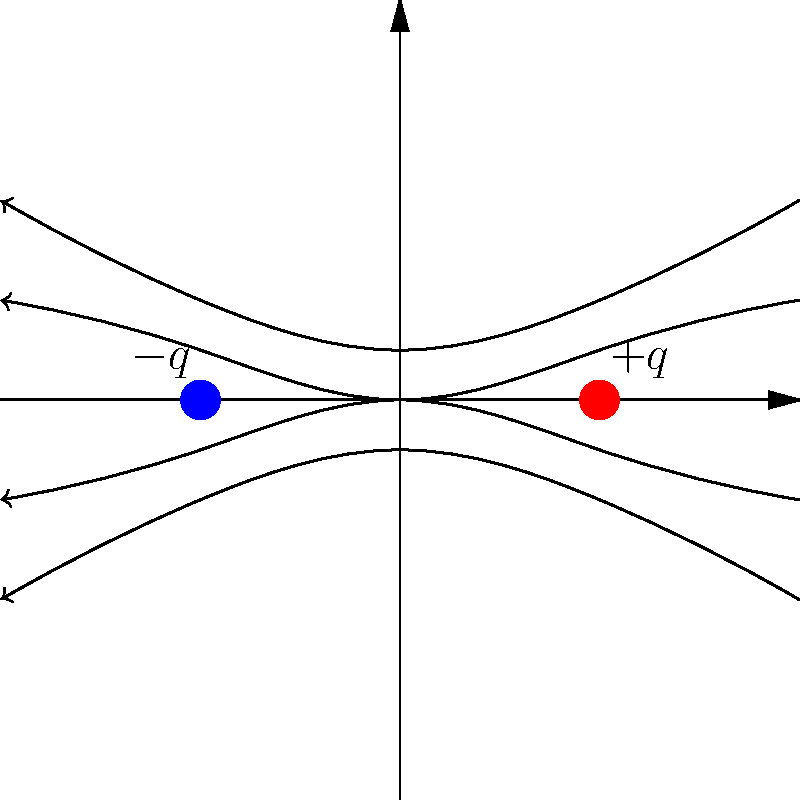As a graphic designer familiar with spreadsheets, you're now working on a physics-themed project. The image shows electric field lines between two charged particles. If you were to create a spreadsheet to calculate the electric field strength at various points, what would be the relationship between the field strength and the density of field lines in any given region? To answer this question, let's break down the key concepts:

1. Electric field lines: These represent the direction and strength of the electric field in space.

2. Density of field lines: This refers to how close together the field lines are in a given region.

3. Electric field strength: This is a measure of the force exerted on a test charge in the electric field.

The relationship between field line density and field strength is as follows:

Step 1: Observe that in regions closer to the charges, the field lines are more densely packed.

Step 2: Notice that as you move away from the charges, the field lines spread out and become less dense.

Step 3: Recall that the electric field strength is proportional to the number of field lines passing through a unit area perpendicular to the lines.

Step 4: Therefore, in regions where the field lines are more densely packed (closer to the charges), the electric field strength is greater.

Step 5: Conversely, in regions where the field lines are more spread out (farther from the charges), the electric field strength is weaker.

In mathematical terms, we can express this relationship as:

$$E \propto \frac{N}{A}$$

Where:
$E$ is the electric field strength
$N$ is the number of field lines
$A$ is the area perpendicular to the field lines

This proportional relationship means that if you were to create a spreadsheet to calculate field strengths, you would need to input data about the density of field lines (or distance from the charges) to determine the relative strength of the electric field at different points.
Answer: The electric field strength is directly proportional to the density of field lines. 